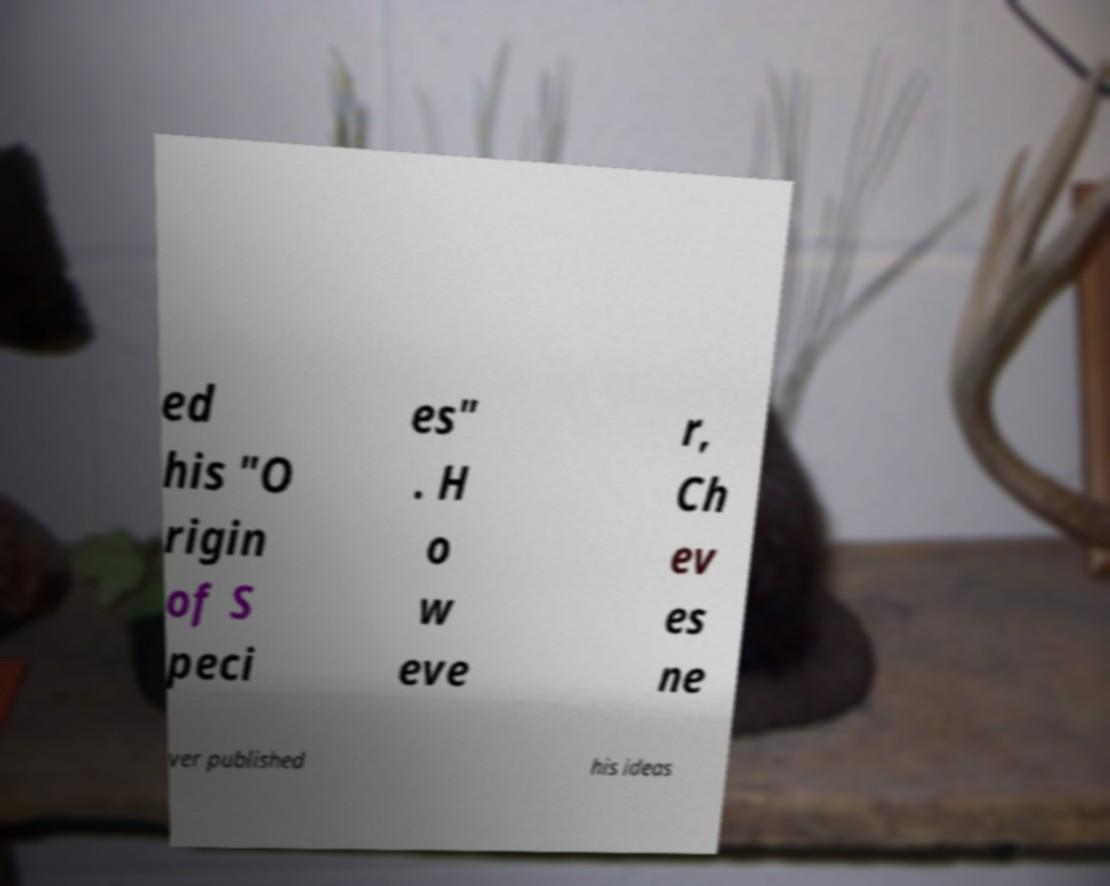For documentation purposes, I need the text within this image transcribed. Could you provide that? ed his "O rigin of S peci es" . H o w eve r, Ch ev es ne ver published his ideas 